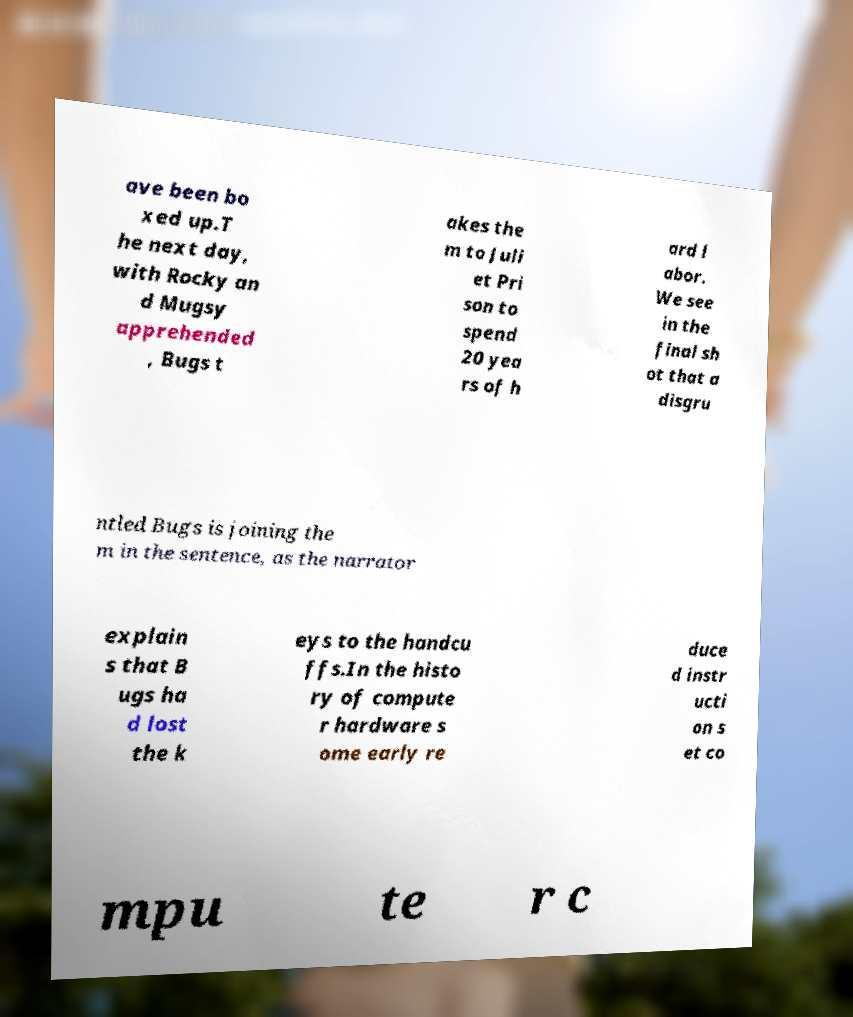There's text embedded in this image that I need extracted. Can you transcribe it verbatim? ave been bo xed up.T he next day, with Rocky an d Mugsy apprehended , Bugs t akes the m to Juli et Pri son to spend 20 yea rs of h ard l abor. We see in the final sh ot that a disgru ntled Bugs is joining the m in the sentence, as the narrator explain s that B ugs ha d lost the k eys to the handcu ffs.In the histo ry of compute r hardware s ome early re duce d instr ucti on s et co mpu te r c 